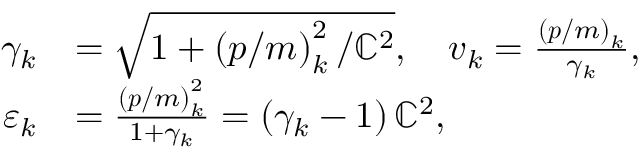Convert formula to latex. <formula><loc_0><loc_0><loc_500><loc_500>\begin{array} { r l } { \gamma _ { k } } & { = \sqrt { 1 + \left ( p / m \right ) _ { k } ^ { 2 } / \mathbb { C } ^ { 2 } } , \quad v _ { k } = \frac { \left ( p / m \right ) _ { k } } { \gamma _ { k } } , } \\ { \varepsilon _ { k } } & { = \frac { \left ( p / m \right ) _ { k } ^ { 2 } } { 1 + \gamma _ { k } } = \left ( \gamma _ { k } - 1 \right ) \mathbb { C } ^ { 2 } , } \end{array}</formula> 